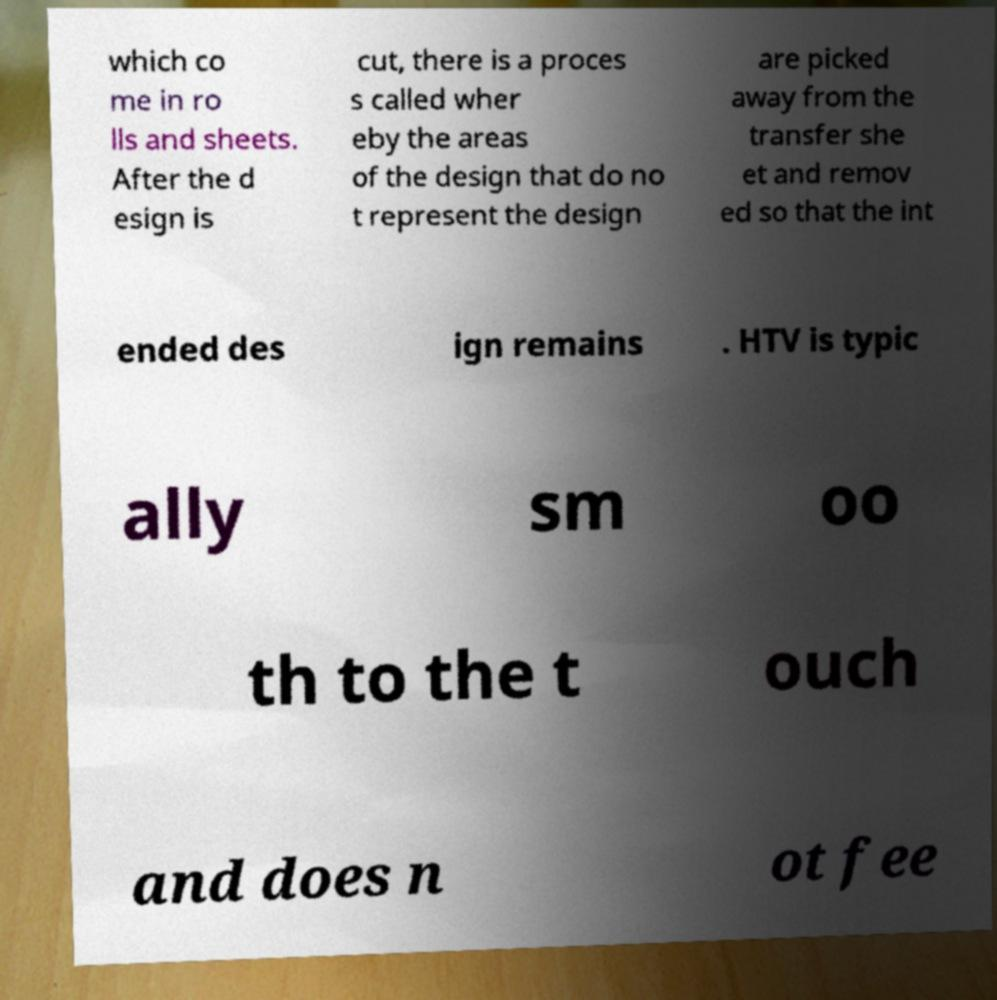I need the written content from this picture converted into text. Can you do that? which co me in ro lls and sheets. After the d esign is cut, there is a proces s called wher eby the areas of the design that do no t represent the design are picked away from the transfer she et and remov ed so that the int ended des ign remains . HTV is typic ally sm oo th to the t ouch and does n ot fee 